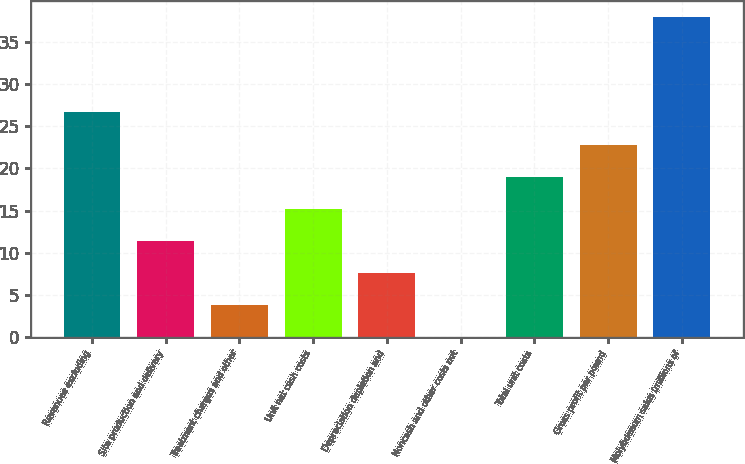Convert chart. <chart><loc_0><loc_0><loc_500><loc_500><bar_chart><fcel>Revenues excluding<fcel>Site production and delivery<fcel>Treatment charges and other<fcel>Unit net cash costs<fcel>Depreciation depletion and<fcel>Noncash and other costs net<fcel>Total unit costs<fcel>Gross profit per pound<fcel>Molybdenum sales (millions of<nl><fcel>26.64<fcel>11.44<fcel>3.84<fcel>15.24<fcel>7.64<fcel>0.04<fcel>19.04<fcel>22.84<fcel>38<nl></chart> 